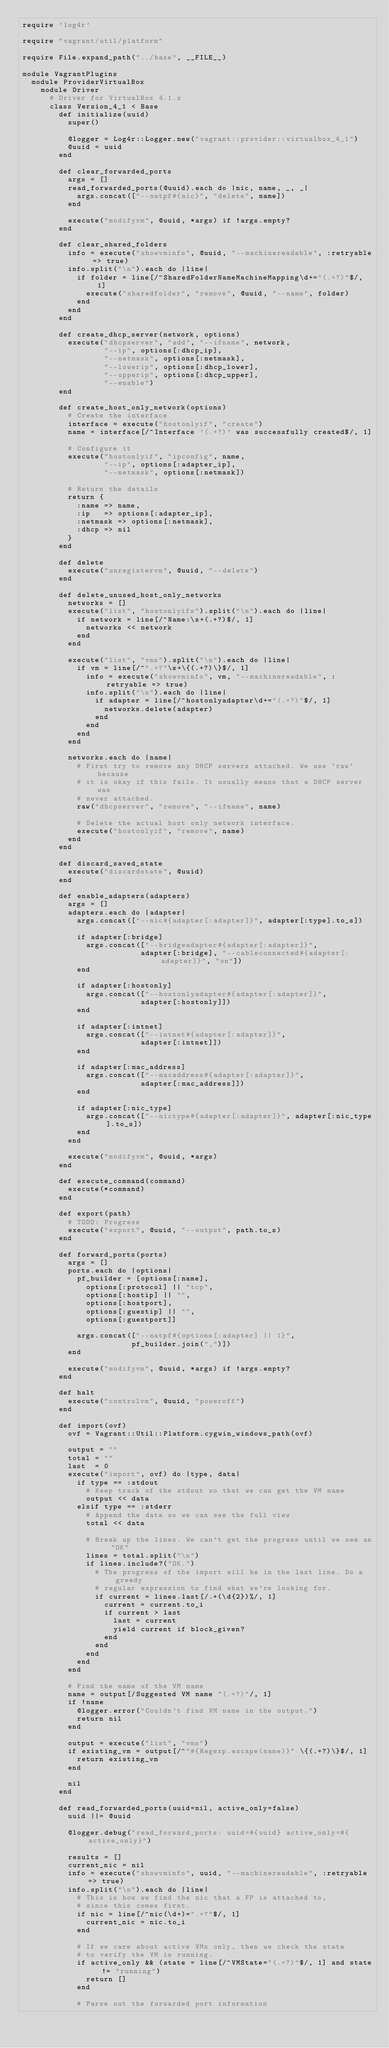<code> <loc_0><loc_0><loc_500><loc_500><_Ruby_>require 'log4r'

require "vagrant/util/platform"

require File.expand_path("../base", __FILE__)

module VagrantPlugins
  module ProviderVirtualBox
    module Driver
      # Driver for VirtualBox 4.1.x
      class Version_4_1 < Base
        def initialize(uuid)
          super()

          @logger = Log4r::Logger.new("vagrant::provider::virtualbox_4_1")
          @uuid = uuid
        end

        def clear_forwarded_ports
          args = []
          read_forwarded_ports(@uuid).each do |nic, name, _, _|
            args.concat(["--natpf#{nic}", "delete", name])
          end

          execute("modifyvm", @uuid, *args) if !args.empty?
        end

        def clear_shared_folders
          info = execute("showvminfo", @uuid, "--machinereadable", :retryable => true)
          info.split("\n").each do |line|
            if folder = line[/^SharedFolderNameMachineMapping\d+="(.+?)"$/, 1]
              execute("sharedfolder", "remove", @uuid, "--name", folder)
            end
          end
        end

        def create_dhcp_server(network, options)
          execute("dhcpserver", "add", "--ifname", network,
                  "--ip", options[:dhcp_ip],
                  "--netmask", options[:netmask],
                  "--lowerip", options[:dhcp_lower],
                  "--upperip", options[:dhcp_upper],
                  "--enable")
        end

        def create_host_only_network(options)
          # Create the interface
          interface = execute("hostonlyif", "create")
          name = interface[/^Interface '(.+?)' was successfully created$/, 1]

          # Configure it
          execute("hostonlyif", "ipconfig", name,
                  "--ip", options[:adapter_ip],
                  "--netmask", options[:netmask])

          # Return the details
          return {
            :name => name,
            :ip   => options[:adapter_ip],
            :netmask => options[:netmask],
            :dhcp => nil
          }
        end

        def delete
          execute("unregistervm", @uuid, "--delete")
        end

        def delete_unused_host_only_networks
          networks = []
          execute("list", "hostonlyifs").split("\n").each do |line|
            if network = line[/^Name:\s+(.+?)$/, 1]
              networks << network
            end
          end

          execute("list", "vms").split("\n").each do |line|
            if vm = line[/^".+?"\s+\{(.+?)\}$/, 1]
              info = execute("showvminfo", vm, "--machinereadable", :retryable => true)
              info.split("\n").each do |line|
                if adapter = line[/^hostonlyadapter\d+="(.+?)"$/, 1]
                  networks.delete(adapter)
                end
              end
            end
          end

          networks.each do |name|
            # First try to remove any DHCP servers attached. We use `raw` because
            # it is okay if this fails. It usually means that a DHCP server was
            # never attached.
            raw("dhcpserver", "remove", "--ifname", name)

            # Delete the actual host only network interface.
            execute("hostonlyif", "remove", name)
          end
        end

        def discard_saved_state
          execute("discardstate", @uuid)
        end

        def enable_adapters(adapters)
          args = []
          adapters.each do |adapter|
            args.concat(["--nic#{adapter[:adapter]}", adapter[:type].to_s])

            if adapter[:bridge]
              args.concat(["--bridgeadapter#{adapter[:adapter]}",
                          adapter[:bridge], "--cableconnected#{adapter[:adapter]}", "on"])
            end

            if adapter[:hostonly]
              args.concat(["--hostonlyadapter#{adapter[:adapter]}",
                          adapter[:hostonly]])
            end

            if adapter[:intnet]
              args.concat(["--intnet#{adapter[:adapter]}",
                          adapter[:intnet]])
            end

            if adapter[:mac_address]
              args.concat(["--macaddress#{adapter[:adapter]}",
                          adapter[:mac_address]])
            end

            if adapter[:nic_type]
              args.concat(["--nictype#{adapter[:adapter]}", adapter[:nic_type].to_s])
            end
          end

          execute("modifyvm", @uuid, *args)
        end

        def execute_command(command)
          execute(*command)
        end

        def export(path)
          # TODO: Progress
          execute("export", @uuid, "--output", path.to_s)
        end

        def forward_ports(ports)
          args = []
          ports.each do |options|
            pf_builder = [options[:name],
              options[:protocol] || "tcp",
              options[:hostip] || "",
              options[:hostport],
              options[:guestip] || "",
              options[:guestport]]

            args.concat(["--natpf#{options[:adapter] || 1}",
                        pf_builder.join(",")])
          end

          execute("modifyvm", @uuid, *args) if !args.empty?
        end

        def halt
          execute("controlvm", @uuid, "poweroff")
        end

        def import(ovf)
          ovf = Vagrant::Util::Platform.cygwin_windows_path(ovf)

          output = ""
          total = ""
          last  = 0
          execute("import", ovf) do |type, data|
            if type == :stdout
              # Keep track of the stdout so that we can get the VM name
              output << data
            elsif type == :stderr
              # Append the data so we can see the full view
              total << data

              # Break up the lines. We can't get the progress until we see an "OK"
              lines = total.split("\n")
              if lines.include?("OK.")
                # The progress of the import will be in the last line. Do a greedy
                # regular expression to find what we're looking for.
                if current = lines.last[/.+(\d{2})%/, 1]
                  current = current.to_i
                  if current > last
                    last = current
                    yield current if block_given?
                  end
                end
              end
            end
          end

          # Find the name of the VM name
          name = output[/Suggested VM name "(.+?)"/, 1]
          if !name
            @logger.error("Couldn't find VM name in the output.")
            return nil
          end

          output = execute("list", "vms")
          if existing_vm = output[/^"#{Regexp.escape(name)}" \{(.+?)\}$/, 1]
            return existing_vm
          end

          nil
        end

        def read_forwarded_ports(uuid=nil, active_only=false)
          uuid ||= @uuid

          @logger.debug("read_forward_ports: uuid=#{uuid} active_only=#{active_only}")

          results = []
          current_nic = nil
          info = execute("showvminfo", uuid, "--machinereadable", :retryable => true)
          info.split("\n").each do |line|
            # This is how we find the nic that a FP is attached to,
            # since this comes first.
            if nic = line[/^nic(\d+)=".+?"$/, 1]
              current_nic = nic.to_i
            end

            # If we care about active VMs only, then we check the state
            # to verify the VM is running.
            if active_only && (state = line[/^VMState="(.+?)"$/, 1] and state != "running")
              return []
            end

            # Parse out the forwarded port information</code> 